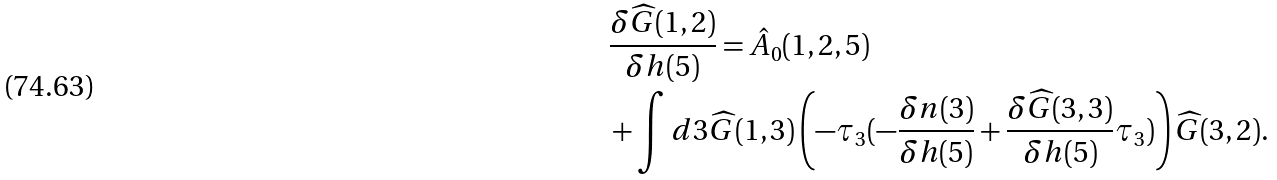<formula> <loc_0><loc_0><loc_500><loc_500>& \frac { \delta \widehat { G } ( 1 , 2 ) } { \delta h ( 5 ) } = \hat { A } _ { 0 } ( 1 , 2 , 5 ) \\ & + \int d 3 \widehat { G } ( 1 , 3 ) \left ( - \tau _ { 3 } ( - \frac { \delta n ( 3 ) } { \delta h ( 5 ) } + \frac { \delta \widehat { G } ( 3 , 3 ) } { \delta h ( 5 ) } \tau _ { 3 } ) \right ) \widehat { G } ( 3 , 2 ) .</formula> 